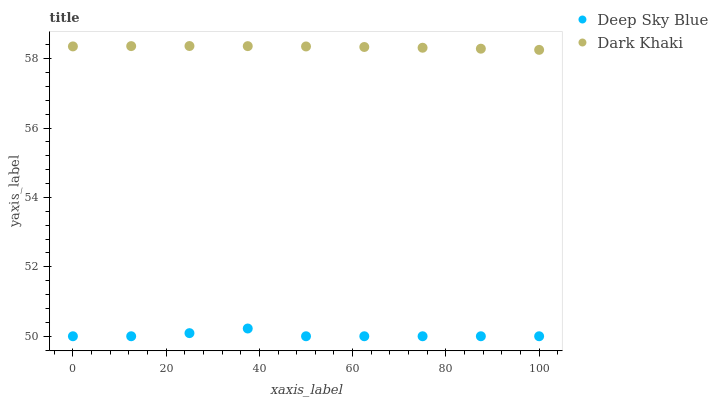Does Deep Sky Blue have the minimum area under the curve?
Answer yes or no. Yes. Does Dark Khaki have the maximum area under the curve?
Answer yes or no. Yes. Does Deep Sky Blue have the maximum area under the curve?
Answer yes or no. No. Is Dark Khaki the smoothest?
Answer yes or no. Yes. Is Deep Sky Blue the roughest?
Answer yes or no. Yes. Is Deep Sky Blue the smoothest?
Answer yes or no. No. Does Deep Sky Blue have the lowest value?
Answer yes or no. Yes. Does Dark Khaki have the highest value?
Answer yes or no. Yes. Does Deep Sky Blue have the highest value?
Answer yes or no. No. Is Deep Sky Blue less than Dark Khaki?
Answer yes or no. Yes. Is Dark Khaki greater than Deep Sky Blue?
Answer yes or no. Yes. Does Deep Sky Blue intersect Dark Khaki?
Answer yes or no. No. 